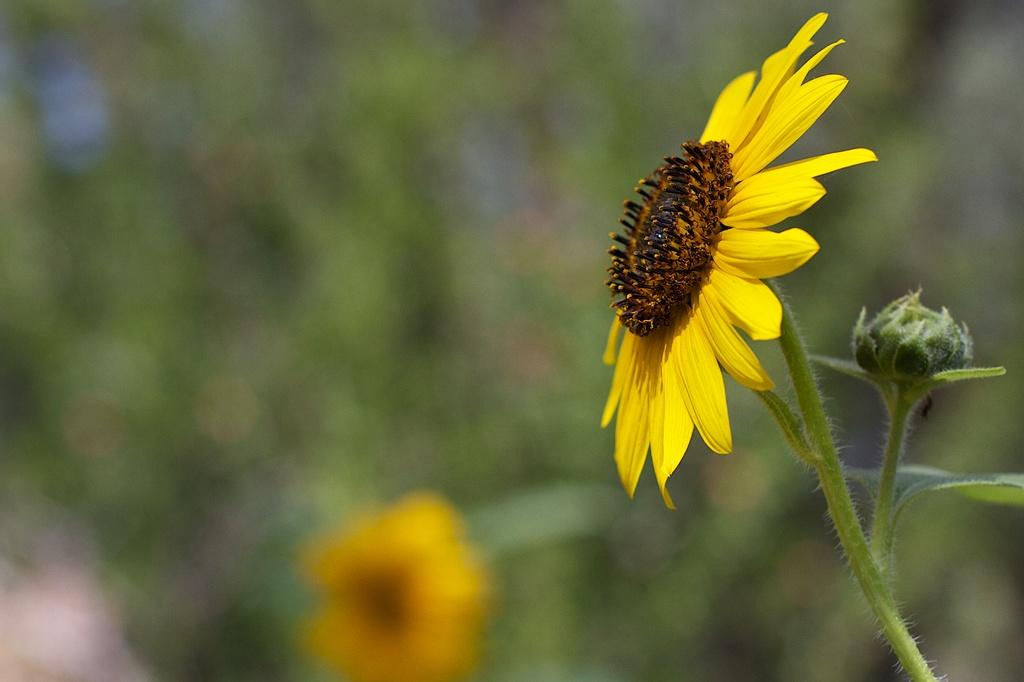What type of living organisms can be seen in the image? There are flowers in the image. What can be seen in the background of the image? There are plants in the background of the image. How would you describe the appearance of the background in the image? The background of the image appears blurry. What type of punishment is being administered to the flowers in the image? There is no punishment being administered to the flowers in the image; they are simply plants. What type of trousers are the flowers wearing in the image? Flowers do not wear trousers, as they are plants and not human beings. 